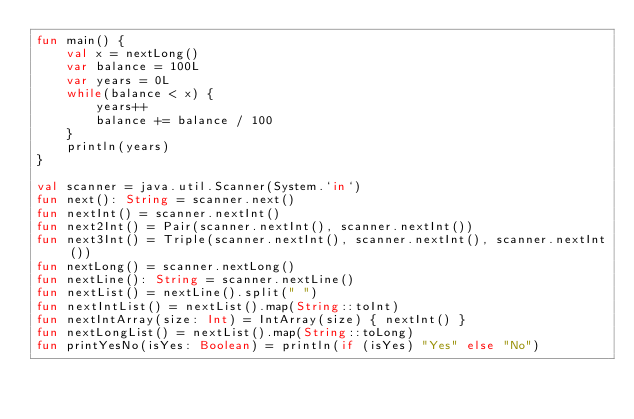Convert code to text. <code><loc_0><loc_0><loc_500><loc_500><_Kotlin_>fun main() {
    val x = nextLong()
    var balance = 100L
    var years = 0L
    while(balance < x) {
        years++
        balance += balance / 100
    }
    println(years)
}

val scanner = java.util.Scanner(System.`in`)
fun next(): String = scanner.next()
fun nextInt() = scanner.nextInt()
fun next2Int() = Pair(scanner.nextInt(), scanner.nextInt())
fun next3Int() = Triple(scanner.nextInt(), scanner.nextInt(), scanner.nextInt())
fun nextLong() = scanner.nextLong()
fun nextLine(): String = scanner.nextLine()
fun nextList() = nextLine().split(" ")
fun nextIntList() = nextList().map(String::toInt)
fun nextIntArray(size: Int) = IntArray(size) { nextInt() }
fun nextLongList() = nextList().map(String::toLong)
fun printYesNo(isYes: Boolean) = println(if (isYes) "Yes" else "No")</code> 